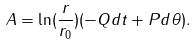Convert formula to latex. <formula><loc_0><loc_0><loc_500><loc_500>A = \ln ( \frac { r } { r _ { 0 } } ) ( - Q d t + P d \theta ) .</formula> 